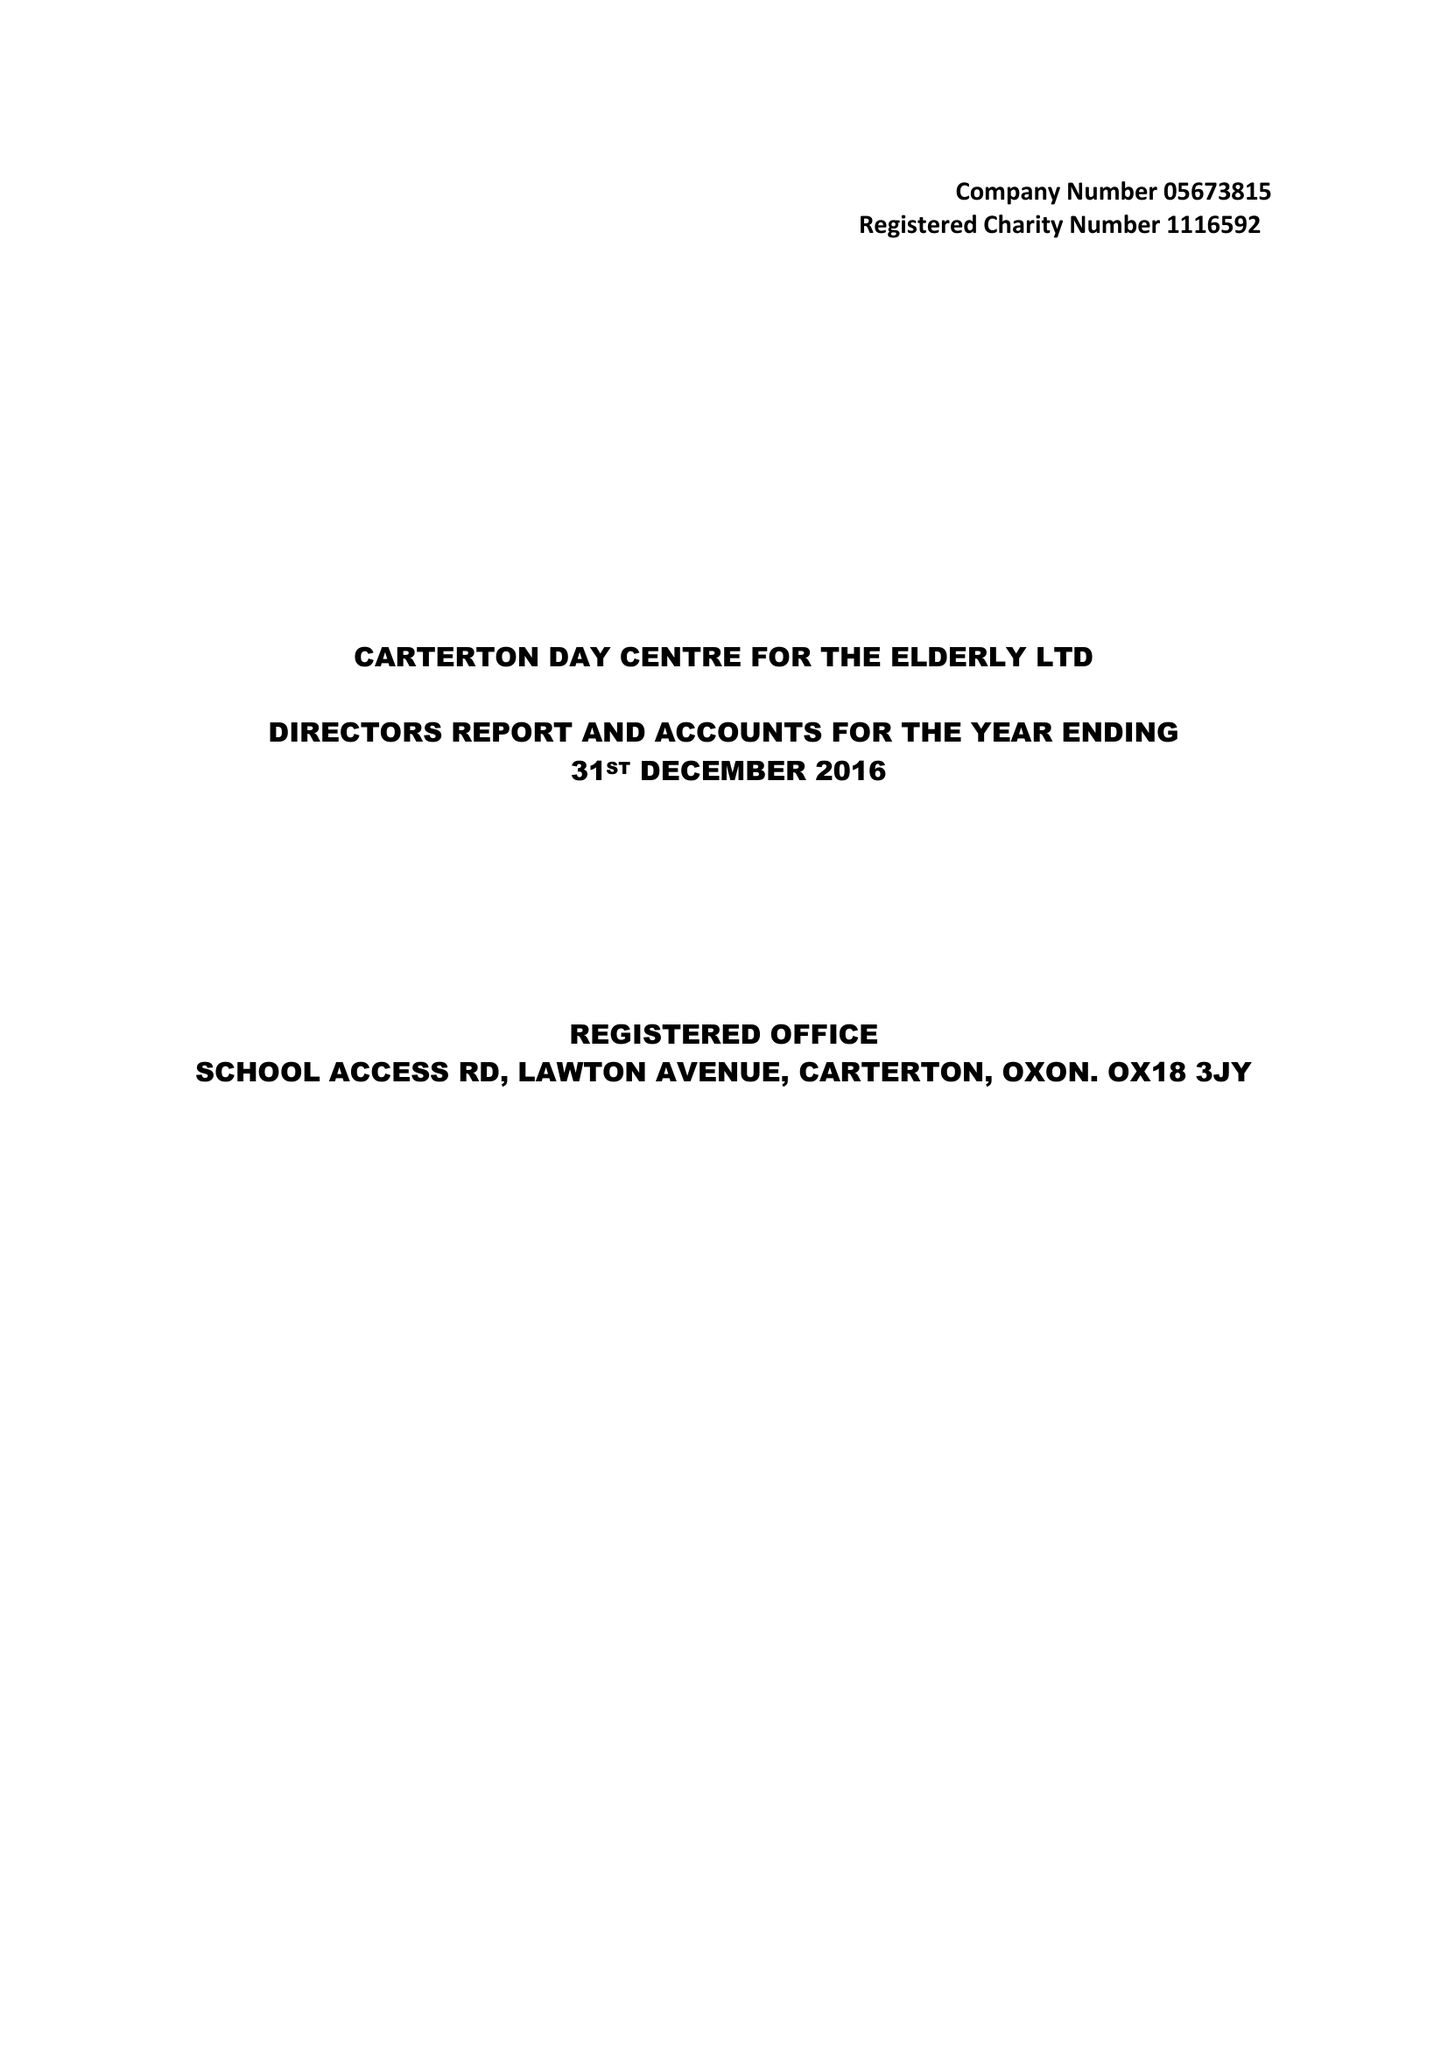What is the value for the address__postcode?
Answer the question using a single word or phrase. OX18 3JY 